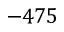<formula> <loc_0><loc_0><loc_500><loc_500>- 4 7 5</formula> 